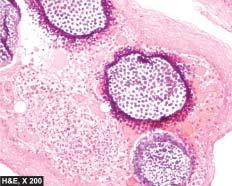re the spores present in sporangia as well as are intermingled in the inflammatory cell infiltrate?
Answer the question using a single word or phrase. Yes 